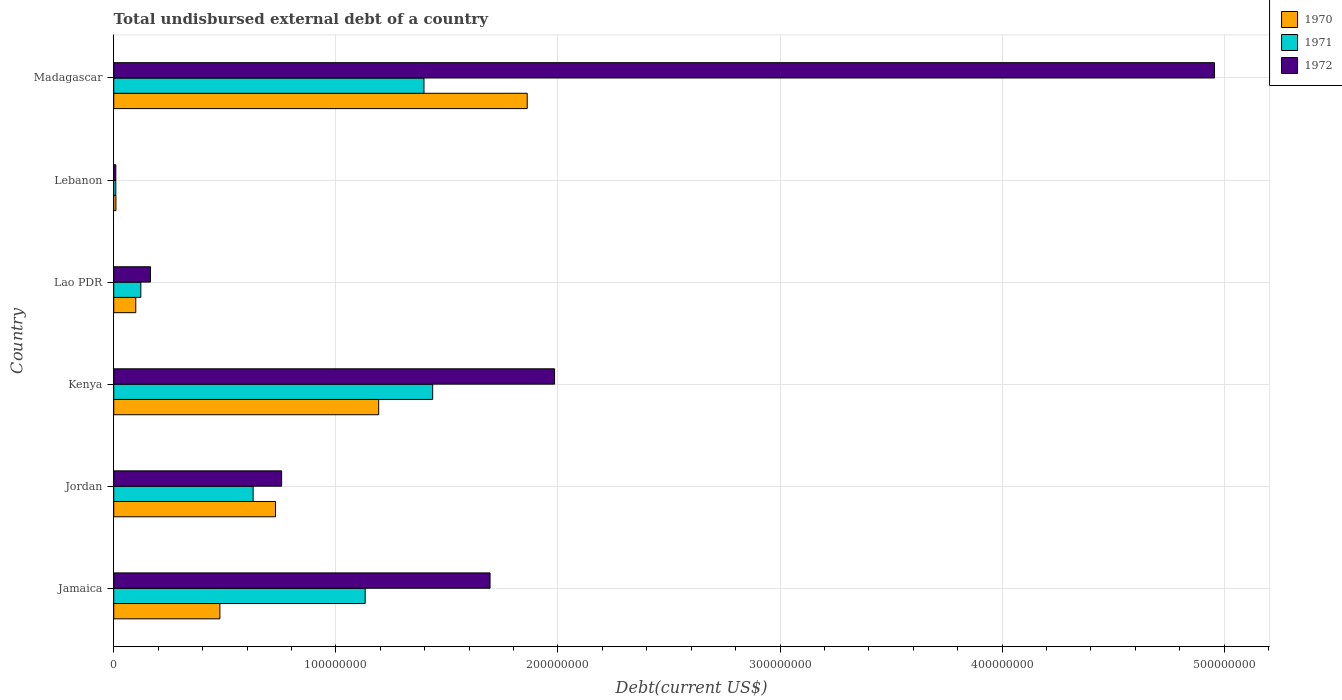How many different coloured bars are there?
Offer a terse response. 3. How many groups of bars are there?
Your response must be concise. 6. Are the number of bars per tick equal to the number of legend labels?
Offer a very short reply. Yes. Are the number of bars on each tick of the Y-axis equal?
Make the answer very short. Yes. How many bars are there on the 4th tick from the bottom?
Your answer should be very brief. 3. What is the label of the 2nd group of bars from the top?
Keep it short and to the point. Lebanon. What is the total undisbursed external debt in 1971 in Lao PDR?
Provide a succinct answer. 1.22e+07. Across all countries, what is the maximum total undisbursed external debt in 1971?
Offer a terse response. 1.44e+08. Across all countries, what is the minimum total undisbursed external debt in 1972?
Make the answer very short. 9.32e+05. In which country was the total undisbursed external debt in 1971 maximum?
Offer a very short reply. Kenya. In which country was the total undisbursed external debt in 1971 minimum?
Make the answer very short. Lebanon. What is the total total undisbursed external debt in 1971 in the graph?
Provide a short and direct response. 4.72e+08. What is the difference between the total undisbursed external debt in 1971 in Kenya and that in Lao PDR?
Provide a succinct answer. 1.31e+08. What is the difference between the total undisbursed external debt in 1970 in Lebanon and the total undisbursed external debt in 1971 in Jamaica?
Provide a succinct answer. -1.12e+08. What is the average total undisbursed external debt in 1971 per country?
Give a very brief answer. 7.87e+07. What is the difference between the total undisbursed external debt in 1970 and total undisbursed external debt in 1972 in Lebanon?
Make the answer very short. 4.80e+04. In how many countries, is the total undisbursed external debt in 1972 greater than 280000000 US$?
Your response must be concise. 1. What is the ratio of the total undisbursed external debt in 1970 in Jordan to that in Madagascar?
Offer a very short reply. 0.39. What is the difference between the highest and the second highest total undisbursed external debt in 1972?
Keep it short and to the point. 2.97e+08. What is the difference between the highest and the lowest total undisbursed external debt in 1971?
Your response must be concise. 1.43e+08. In how many countries, is the total undisbursed external debt in 1970 greater than the average total undisbursed external debt in 1970 taken over all countries?
Provide a short and direct response. 3. Is the sum of the total undisbursed external debt in 1972 in Jordan and Lao PDR greater than the maximum total undisbursed external debt in 1970 across all countries?
Your answer should be compact. No. What does the 1st bar from the top in Lao PDR represents?
Provide a succinct answer. 1972. Is it the case that in every country, the sum of the total undisbursed external debt in 1970 and total undisbursed external debt in 1972 is greater than the total undisbursed external debt in 1971?
Provide a short and direct response. Yes. How many bars are there?
Your answer should be very brief. 18. Are all the bars in the graph horizontal?
Ensure brevity in your answer.  Yes. How many countries are there in the graph?
Make the answer very short. 6. What is the difference between two consecutive major ticks on the X-axis?
Keep it short and to the point. 1.00e+08. Are the values on the major ticks of X-axis written in scientific E-notation?
Offer a terse response. No. Does the graph contain any zero values?
Ensure brevity in your answer.  No. Does the graph contain grids?
Make the answer very short. Yes. How many legend labels are there?
Offer a terse response. 3. What is the title of the graph?
Provide a succinct answer. Total undisbursed external debt of a country. Does "2013" appear as one of the legend labels in the graph?
Your response must be concise. No. What is the label or title of the X-axis?
Keep it short and to the point. Debt(current US$). What is the label or title of the Y-axis?
Ensure brevity in your answer.  Country. What is the Debt(current US$) of 1970 in Jamaica?
Ensure brevity in your answer.  4.78e+07. What is the Debt(current US$) in 1971 in Jamaica?
Keep it short and to the point. 1.13e+08. What is the Debt(current US$) in 1972 in Jamaica?
Ensure brevity in your answer.  1.69e+08. What is the Debt(current US$) of 1970 in Jordan?
Make the answer very short. 7.28e+07. What is the Debt(current US$) in 1971 in Jordan?
Your answer should be compact. 6.28e+07. What is the Debt(current US$) in 1972 in Jordan?
Your answer should be compact. 7.56e+07. What is the Debt(current US$) in 1970 in Kenya?
Make the answer very short. 1.19e+08. What is the Debt(current US$) in 1971 in Kenya?
Provide a short and direct response. 1.44e+08. What is the Debt(current US$) of 1972 in Kenya?
Make the answer very short. 1.98e+08. What is the Debt(current US$) in 1970 in Lao PDR?
Give a very brief answer. 9.92e+06. What is the Debt(current US$) of 1971 in Lao PDR?
Offer a very short reply. 1.22e+07. What is the Debt(current US$) of 1972 in Lao PDR?
Make the answer very short. 1.65e+07. What is the Debt(current US$) in 1970 in Lebanon?
Offer a terse response. 9.80e+05. What is the Debt(current US$) of 1971 in Lebanon?
Ensure brevity in your answer.  9.32e+05. What is the Debt(current US$) of 1972 in Lebanon?
Offer a very short reply. 9.32e+05. What is the Debt(current US$) in 1970 in Madagascar?
Provide a short and direct response. 1.86e+08. What is the Debt(current US$) in 1971 in Madagascar?
Ensure brevity in your answer.  1.40e+08. What is the Debt(current US$) of 1972 in Madagascar?
Offer a very short reply. 4.96e+08. Across all countries, what is the maximum Debt(current US$) in 1970?
Your answer should be very brief. 1.86e+08. Across all countries, what is the maximum Debt(current US$) of 1971?
Offer a terse response. 1.44e+08. Across all countries, what is the maximum Debt(current US$) in 1972?
Ensure brevity in your answer.  4.96e+08. Across all countries, what is the minimum Debt(current US$) in 1970?
Make the answer very short. 9.80e+05. Across all countries, what is the minimum Debt(current US$) of 1971?
Your response must be concise. 9.32e+05. Across all countries, what is the minimum Debt(current US$) in 1972?
Give a very brief answer. 9.32e+05. What is the total Debt(current US$) of 1970 in the graph?
Keep it short and to the point. 4.37e+08. What is the total Debt(current US$) of 1971 in the graph?
Make the answer very short. 4.72e+08. What is the total Debt(current US$) in 1972 in the graph?
Your answer should be compact. 9.57e+08. What is the difference between the Debt(current US$) of 1970 in Jamaica and that in Jordan?
Provide a short and direct response. -2.50e+07. What is the difference between the Debt(current US$) in 1971 in Jamaica and that in Jordan?
Ensure brevity in your answer.  5.05e+07. What is the difference between the Debt(current US$) in 1972 in Jamaica and that in Jordan?
Keep it short and to the point. 9.38e+07. What is the difference between the Debt(current US$) of 1970 in Jamaica and that in Kenya?
Provide a succinct answer. -7.15e+07. What is the difference between the Debt(current US$) in 1971 in Jamaica and that in Kenya?
Provide a short and direct response. -3.04e+07. What is the difference between the Debt(current US$) in 1972 in Jamaica and that in Kenya?
Offer a very short reply. -2.91e+07. What is the difference between the Debt(current US$) of 1970 in Jamaica and that in Lao PDR?
Offer a terse response. 3.79e+07. What is the difference between the Debt(current US$) of 1971 in Jamaica and that in Lao PDR?
Your answer should be compact. 1.01e+08. What is the difference between the Debt(current US$) in 1972 in Jamaica and that in Lao PDR?
Your answer should be very brief. 1.53e+08. What is the difference between the Debt(current US$) of 1970 in Jamaica and that in Lebanon?
Keep it short and to the point. 4.68e+07. What is the difference between the Debt(current US$) of 1971 in Jamaica and that in Lebanon?
Give a very brief answer. 1.12e+08. What is the difference between the Debt(current US$) of 1972 in Jamaica and that in Lebanon?
Ensure brevity in your answer.  1.69e+08. What is the difference between the Debt(current US$) of 1970 in Jamaica and that in Madagascar?
Provide a short and direct response. -1.38e+08. What is the difference between the Debt(current US$) of 1971 in Jamaica and that in Madagascar?
Your answer should be very brief. -2.65e+07. What is the difference between the Debt(current US$) in 1972 in Jamaica and that in Madagascar?
Offer a very short reply. -3.26e+08. What is the difference between the Debt(current US$) of 1970 in Jordan and that in Kenya?
Offer a very short reply. -4.65e+07. What is the difference between the Debt(current US$) in 1971 in Jordan and that in Kenya?
Provide a short and direct response. -8.08e+07. What is the difference between the Debt(current US$) of 1972 in Jordan and that in Kenya?
Provide a succinct answer. -1.23e+08. What is the difference between the Debt(current US$) in 1970 in Jordan and that in Lao PDR?
Your response must be concise. 6.29e+07. What is the difference between the Debt(current US$) in 1971 in Jordan and that in Lao PDR?
Offer a very short reply. 5.06e+07. What is the difference between the Debt(current US$) of 1972 in Jordan and that in Lao PDR?
Ensure brevity in your answer.  5.90e+07. What is the difference between the Debt(current US$) of 1970 in Jordan and that in Lebanon?
Offer a very short reply. 7.19e+07. What is the difference between the Debt(current US$) in 1971 in Jordan and that in Lebanon?
Ensure brevity in your answer.  6.18e+07. What is the difference between the Debt(current US$) of 1972 in Jordan and that in Lebanon?
Provide a succinct answer. 7.47e+07. What is the difference between the Debt(current US$) in 1970 in Jordan and that in Madagascar?
Offer a very short reply. -1.13e+08. What is the difference between the Debt(current US$) in 1971 in Jordan and that in Madagascar?
Keep it short and to the point. -7.69e+07. What is the difference between the Debt(current US$) in 1972 in Jordan and that in Madagascar?
Give a very brief answer. -4.20e+08. What is the difference between the Debt(current US$) in 1970 in Kenya and that in Lao PDR?
Your response must be concise. 1.09e+08. What is the difference between the Debt(current US$) of 1971 in Kenya and that in Lao PDR?
Offer a very short reply. 1.31e+08. What is the difference between the Debt(current US$) of 1972 in Kenya and that in Lao PDR?
Provide a succinct answer. 1.82e+08. What is the difference between the Debt(current US$) of 1970 in Kenya and that in Lebanon?
Your answer should be compact. 1.18e+08. What is the difference between the Debt(current US$) in 1971 in Kenya and that in Lebanon?
Provide a succinct answer. 1.43e+08. What is the difference between the Debt(current US$) of 1972 in Kenya and that in Lebanon?
Offer a terse response. 1.98e+08. What is the difference between the Debt(current US$) of 1970 in Kenya and that in Madagascar?
Make the answer very short. -6.69e+07. What is the difference between the Debt(current US$) in 1971 in Kenya and that in Madagascar?
Your answer should be very brief. 3.91e+06. What is the difference between the Debt(current US$) of 1972 in Kenya and that in Madagascar?
Make the answer very short. -2.97e+08. What is the difference between the Debt(current US$) of 1970 in Lao PDR and that in Lebanon?
Provide a succinct answer. 8.94e+06. What is the difference between the Debt(current US$) in 1971 in Lao PDR and that in Lebanon?
Offer a very short reply. 1.13e+07. What is the difference between the Debt(current US$) of 1972 in Lao PDR and that in Lebanon?
Your answer should be very brief. 1.56e+07. What is the difference between the Debt(current US$) of 1970 in Lao PDR and that in Madagascar?
Keep it short and to the point. -1.76e+08. What is the difference between the Debt(current US$) in 1971 in Lao PDR and that in Madagascar?
Provide a short and direct response. -1.27e+08. What is the difference between the Debt(current US$) in 1972 in Lao PDR and that in Madagascar?
Make the answer very short. -4.79e+08. What is the difference between the Debt(current US$) of 1970 in Lebanon and that in Madagascar?
Make the answer very short. -1.85e+08. What is the difference between the Debt(current US$) in 1971 in Lebanon and that in Madagascar?
Ensure brevity in your answer.  -1.39e+08. What is the difference between the Debt(current US$) in 1972 in Lebanon and that in Madagascar?
Provide a succinct answer. -4.95e+08. What is the difference between the Debt(current US$) in 1970 in Jamaica and the Debt(current US$) in 1971 in Jordan?
Ensure brevity in your answer.  -1.50e+07. What is the difference between the Debt(current US$) in 1970 in Jamaica and the Debt(current US$) in 1972 in Jordan?
Provide a short and direct response. -2.78e+07. What is the difference between the Debt(current US$) of 1971 in Jamaica and the Debt(current US$) of 1972 in Jordan?
Offer a terse response. 3.76e+07. What is the difference between the Debt(current US$) of 1970 in Jamaica and the Debt(current US$) of 1971 in Kenya?
Give a very brief answer. -9.58e+07. What is the difference between the Debt(current US$) of 1970 in Jamaica and the Debt(current US$) of 1972 in Kenya?
Your answer should be very brief. -1.51e+08. What is the difference between the Debt(current US$) of 1971 in Jamaica and the Debt(current US$) of 1972 in Kenya?
Provide a succinct answer. -8.53e+07. What is the difference between the Debt(current US$) of 1970 in Jamaica and the Debt(current US$) of 1971 in Lao PDR?
Offer a terse response. 3.56e+07. What is the difference between the Debt(current US$) in 1970 in Jamaica and the Debt(current US$) in 1972 in Lao PDR?
Provide a short and direct response. 3.12e+07. What is the difference between the Debt(current US$) in 1971 in Jamaica and the Debt(current US$) in 1972 in Lao PDR?
Your answer should be compact. 9.67e+07. What is the difference between the Debt(current US$) in 1970 in Jamaica and the Debt(current US$) in 1971 in Lebanon?
Keep it short and to the point. 4.69e+07. What is the difference between the Debt(current US$) in 1970 in Jamaica and the Debt(current US$) in 1972 in Lebanon?
Provide a succinct answer. 4.69e+07. What is the difference between the Debt(current US$) of 1971 in Jamaica and the Debt(current US$) of 1972 in Lebanon?
Your answer should be compact. 1.12e+08. What is the difference between the Debt(current US$) of 1970 in Jamaica and the Debt(current US$) of 1971 in Madagascar?
Your response must be concise. -9.19e+07. What is the difference between the Debt(current US$) of 1970 in Jamaica and the Debt(current US$) of 1972 in Madagascar?
Your answer should be very brief. -4.48e+08. What is the difference between the Debt(current US$) of 1971 in Jamaica and the Debt(current US$) of 1972 in Madagascar?
Your answer should be very brief. -3.82e+08. What is the difference between the Debt(current US$) of 1970 in Jordan and the Debt(current US$) of 1971 in Kenya?
Offer a terse response. -7.08e+07. What is the difference between the Debt(current US$) in 1970 in Jordan and the Debt(current US$) in 1972 in Kenya?
Your answer should be compact. -1.26e+08. What is the difference between the Debt(current US$) in 1971 in Jordan and the Debt(current US$) in 1972 in Kenya?
Your answer should be very brief. -1.36e+08. What is the difference between the Debt(current US$) in 1970 in Jordan and the Debt(current US$) in 1971 in Lao PDR?
Your response must be concise. 6.06e+07. What is the difference between the Debt(current US$) of 1970 in Jordan and the Debt(current US$) of 1972 in Lao PDR?
Make the answer very short. 5.63e+07. What is the difference between the Debt(current US$) in 1971 in Jordan and the Debt(current US$) in 1972 in Lao PDR?
Offer a terse response. 4.62e+07. What is the difference between the Debt(current US$) in 1970 in Jordan and the Debt(current US$) in 1971 in Lebanon?
Provide a short and direct response. 7.19e+07. What is the difference between the Debt(current US$) of 1970 in Jordan and the Debt(current US$) of 1972 in Lebanon?
Provide a succinct answer. 7.19e+07. What is the difference between the Debt(current US$) of 1971 in Jordan and the Debt(current US$) of 1972 in Lebanon?
Your answer should be very brief. 6.18e+07. What is the difference between the Debt(current US$) of 1970 in Jordan and the Debt(current US$) of 1971 in Madagascar?
Offer a terse response. -6.69e+07. What is the difference between the Debt(current US$) of 1970 in Jordan and the Debt(current US$) of 1972 in Madagascar?
Your answer should be very brief. -4.23e+08. What is the difference between the Debt(current US$) of 1971 in Jordan and the Debt(current US$) of 1972 in Madagascar?
Provide a succinct answer. -4.33e+08. What is the difference between the Debt(current US$) of 1970 in Kenya and the Debt(current US$) of 1971 in Lao PDR?
Your answer should be compact. 1.07e+08. What is the difference between the Debt(current US$) of 1970 in Kenya and the Debt(current US$) of 1972 in Lao PDR?
Keep it short and to the point. 1.03e+08. What is the difference between the Debt(current US$) in 1971 in Kenya and the Debt(current US$) in 1972 in Lao PDR?
Your answer should be very brief. 1.27e+08. What is the difference between the Debt(current US$) of 1970 in Kenya and the Debt(current US$) of 1971 in Lebanon?
Your response must be concise. 1.18e+08. What is the difference between the Debt(current US$) in 1970 in Kenya and the Debt(current US$) in 1972 in Lebanon?
Provide a succinct answer. 1.18e+08. What is the difference between the Debt(current US$) in 1971 in Kenya and the Debt(current US$) in 1972 in Lebanon?
Provide a short and direct response. 1.43e+08. What is the difference between the Debt(current US$) of 1970 in Kenya and the Debt(current US$) of 1971 in Madagascar?
Offer a terse response. -2.04e+07. What is the difference between the Debt(current US$) of 1970 in Kenya and the Debt(current US$) of 1972 in Madagascar?
Your answer should be very brief. -3.76e+08. What is the difference between the Debt(current US$) of 1971 in Kenya and the Debt(current US$) of 1972 in Madagascar?
Offer a very short reply. -3.52e+08. What is the difference between the Debt(current US$) of 1970 in Lao PDR and the Debt(current US$) of 1971 in Lebanon?
Your answer should be very brief. 8.98e+06. What is the difference between the Debt(current US$) in 1970 in Lao PDR and the Debt(current US$) in 1972 in Lebanon?
Offer a terse response. 8.98e+06. What is the difference between the Debt(current US$) in 1971 in Lao PDR and the Debt(current US$) in 1972 in Lebanon?
Offer a terse response. 1.13e+07. What is the difference between the Debt(current US$) in 1970 in Lao PDR and the Debt(current US$) in 1971 in Madagascar?
Provide a succinct answer. -1.30e+08. What is the difference between the Debt(current US$) of 1970 in Lao PDR and the Debt(current US$) of 1972 in Madagascar?
Your answer should be compact. -4.86e+08. What is the difference between the Debt(current US$) in 1971 in Lao PDR and the Debt(current US$) in 1972 in Madagascar?
Your response must be concise. -4.83e+08. What is the difference between the Debt(current US$) of 1970 in Lebanon and the Debt(current US$) of 1971 in Madagascar?
Keep it short and to the point. -1.39e+08. What is the difference between the Debt(current US$) of 1970 in Lebanon and the Debt(current US$) of 1972 in Madagascar?
Your answer should be very brief. -4.95e+08. What is the difference between the Debt(current US$) in 1971 in Lebanon and the Debt(current US$) in 1972 in Madagascar?
Offer a very short reply. -4.95e+08. What is the average Debt(current US$) of 1970 per country?
Your answer should be compact. 7.28e+07. What is the average Debt(current US$) in 1971 per country?
Offer a very short reply. 7.87e+07. What is the average Debt(current US$) in 1972 per country?
Provide a succinct answer. 1.59e+08. What is the difference between the Debt(current US$) of 1970 and Debt(current US$) of 1971 in Jamaica?
Your response must be concise. -6.54e+07. What is the difference between the Debt(current US$) in 1970 and Debt(current US$) in 1972 in Jamaica?
Your answer should be compact. -1.22e+08. What is the difference between the Debt(current US$) in 1971 and Debt(current US$) in 1972 in Jamaica?
Provide a succinct answer. -5.62e+07. What is the difference between the Debt(current US$) of 1970 and Debt(current US$) of 1971 in Jordan?
Give a very brief answer. 1.01e+07. What is the difference between the Debt(current US$) of 1970 and Debt(current US$) of 1972 in Jordan?
Make the answer very short. -2.75e+06. What is the difference between the Debt(current US$) in 1971 and Debt(current US$) in 1972 in Jordan?
Provide a short and direct response. -1.28e+07. What is the difference between the Debt(current US$) in 1970 and Debt(current US$) in 1971 in Kenya?
Your answer should be compact. -2.43e+07. What is the difference between the Debt(current US$) of 1970 and Debt(current US$) of 1972 in Kenya?
Offer a terse response. -7.92e+07. What is the difference between the Debt(current US$) of 1971 and Debt(current US$) of 1972 in Kenya?
Your answer should be compact. -5.49e+07. What is the difference between the Debt(current US$) in 1970 and Debt(current US$) in 1971 in Lao PDR?
Provide a succinct answer. -2.28e+06. What is the difference between the Debt(current US$) of 1970 and Debt(current US$) of 1972 in Lao PDR?
Offer a very short reply. -6.63e+06. What is the difference between the Debt(current US$) of 1971 and Debt(current US$) of 1972 in Lao PDR?
Your response must be concise. -4.35e+06. What is the difference between the Debt(current US$) in 1970 and Debt(current US$) in 1971 in Lebanon?
Provide a succinct answer. 4.80e+04. What is the difference between the Debt(current US$) in 1970 and Debt(current US$) in 1972 in Lebanon?
Ensure brevity in your answer.  4.80e+04. What is the difference between the Debt(current US$) of 1971 and Debt(current US$) of 1972 in Lebanon?
Keep it short and to the point. 0. What is the difference between the Debt(current US$) in 1970 and Debt(current US$) in 1971 in Madagascar?
Offer a very short reply. 4.65e+07. What is the difference between the Debt(current US$) of 1970 and Debt(current US$) of 1972 in Madagascar?
Your answer should be very brief. -3.09e+08. What is the difference between the Debt(current US$) of 1971 and Debt(current US$) of 1972 in Madagascar?
Provide a succinct answer. -3.56e+08. What is the ratio of the Debt(current US$) of 1970 in Jamaica to that in Jordan?
Offer a terse response. 0.66. What is the ratio of the Debt(current US$) of 1971 in Jamaica to that in Jordan?
Keep it short and to the point. 1.8. What is the ratio of the Debt(current US$) of 1972 in Jamaica to that in Jordan?
Offer a terse response. 2.24. What is the ratio of the Debt(current US$) of 1970 in Jamaica to that in Kenya?
Provide a short and direct response. 0.4. What is the ratio of the Debt(current US$) of 1971 in Jamaica to that in Kenya?
Ensure brevity in your answer.  0.79. What is the ratio of the Debt(current US$) of 1972 in Jamaica to that in Kenya?
Provide a succinct answer. 0.85. What is the ratio of the Debt(current US$) of 1970 in Jamaica to that in Lao PDR?
Ensure brevity in your answer.  4.82. What is the ratio of the Debt(current US$) of 1971 in Jamaica to that in Lao PDR?
Make the answer very short. 9.28. What is the ratio of the Debt(current US$) in 1972 in Jamaica to that in Lao PDR?
Offer a terse response. 10.24. What is the ratio of the Debt(current US$) of 1970 in Jamaica to that in Lebanon?
Keep it short and to the point. 48.77. What is the ratio of the Debt(current US$) in 1971 in Jamaica to that in Lebanon?
Offer a very short reply. 121.47. What is the ratio of the Debt(current US$) in 1972 in Jamaica to that in Lebanon?
Make the answer very short. 181.8. What is the ratio of the Debt(current US$) of 1970 in Jamaica to that in Madagascar?
Keep it short and to the point. 0.26. What is the ratio of the Debt(current US$) in 1971 in Jamaica to that in Madagascar?
Provide a short and direct response. 0.81. What is the ratio of the Debt(current US$) in 1972 in Jamaica to that in Madagascar?
Your response must be concise. 0.34. What is the ratio of the Debt(current US$) in 1970 in Jordan to that in Kenya?
Make the answer very short. 0.61. What is the ratio of the Debt(current US$) in 1971 in Jordan to that in Kenya?
Your answer should be compact. 0.44. What is the ratio of the Debt(current US$) of 1972 in Jordan to that in Kenya?
Ensure brevity in your answer.  0.38. What is the ratio of the Debt(current US$) in 1970 in Jordan to that in Lao PDR?
Your response must be concise. 7.35. What is the ratio of the Debt(current US$) of 1971 in Jordan to that in Lao PDR?
Offer a very short reply. 5.15. What is the ratio of the Debt(current US$) of 1972 in Jordan to that in Lao PDR?
Offer a terse response. 4.57. What is the ratio of the Debt(current US$) in 1970 in Jordan to that in Lebanon?
Your response must be concise. 74.33. What is the ratio of the Debt(current US$) of 1971 in Jordan to that in Lebanon?
Your response must be concise. 67.34. What is the ratio of the Debt(current US$) of 1972 in Jordan to that in Lebanon?
Offer a terse response. 81.11. What is the ratio of the Debt(current US$) of 1970 in Jordan to that in Madagascar?
Your answer should be very brief. 0.39. What is the ratio of the Debt(current US$) in 1971 in Jordan to that in Madagascar?
Provide a succinct answer. 0.45. What is the ratio of the Debt(current US$) of 1972 in Jordan to that in Madagascar?
Your response must be concise. 0.15. What is the ratio of the Debt(current US$) of 1970 in Kenya to that in Lao PDR?
Your answer should be very brief. 12.03. What is the ratio of the Debt(current US$) of 1971 in Kenya to that in Lao PDR?
Offer a terse response. 11.77. What is the ratio of the Debt(current US$) of 1972 in Kenya to that in Lao PDR?
Your answer should be compact. 12. What is the ratio of the Debt(current US$) of 1970 in Kenya to that in Lebanon?
Provide a succinct answer. 121.73. What is the ratio of the Debt(current US$) in 1971 in Kenya to that in Lebanon?
Give a very brief answer. 154.08. What is the ratio of the Debt(current US$) in 1972 in Kenya to that in Lebanon?
Provide a succinct answer. 212.97. What is the ratio of the Debt(current US$) in 1970 in Kenya to that in Madagascar?
Offer a very short reply. 0.64. What is the ratio of the Debt(current US$) in 1971 in Kenya to that in Madagascar?
Offer a very short reply. 1.03. What is the ratio of the Debt(current US$) of 1972 in Kenya to that in Madagascar?
Provide a short and direct response. 0.4. What is the ratio of the Debt(current US$) in 1970 in Lao PDR to that in Lebanon?
Provide a succinct answer. 10.12. What is the ratio of the Debt(current US$) in 1971 in Lao PDR to that in Lebanon?
Provide a succinct answer. 13.09. What is the ratio of the Debt(current US$) in 1972 in Lao PDR to that in Lebanon?
Provide a short and direct response. 17.75. What is the ratio of the Debt(current US$) of 1970 in Lao PDR to that in Madagascar?
Offer a very short reply. 0.05. What is the ratio of the Debt(current US$) of 1971 in Lao PDR to that in Madagascar?
Your response must be concise. 0.09. What is the ratio of the Debt(current US$) in 1972 in Lao PDR to that in Madagascar?
Keep it short and to the point. 0.03. What is the ratio of the Debt(current US$) of 1970 in Lebanon to that in Madagascar?
Ensure brevity in your answer.  0.01. What is the ratio of the Debt(current US$) in 1971 in Lebanon to that in Madagascar?
Your answer should be compact. 0.01. What is the ratio of the Debt(current US$) of 1972 in Lebanon to that in Madagascar?
Give a very brief answer. 0. What is the difference between the highest and the second highest Debt(current US$) in 1970?
Ensure brevity in your answer.  6.69e+07. What is the difference between the highest and the second highest Debt(current US$) in 1971?
Provide a succinct answer. 3.91e+06. What is the difference between the highest and the second highest Debt(current US$) of 1972?
Make the answer very short. 2.97e+08. What is the difference between the highest and the lowest Debt(current US$) in 1970?
Offer a very short reply. 1.85e+08. What is the difference between the highest and the lowest Debt(current US$) in 1971?
Keep it short and to the point. 1.43e+08. What is the difference between the highest and the lowest Debt(current US$) in 1972?
Your answer should be very brief. 4.95e+08. 